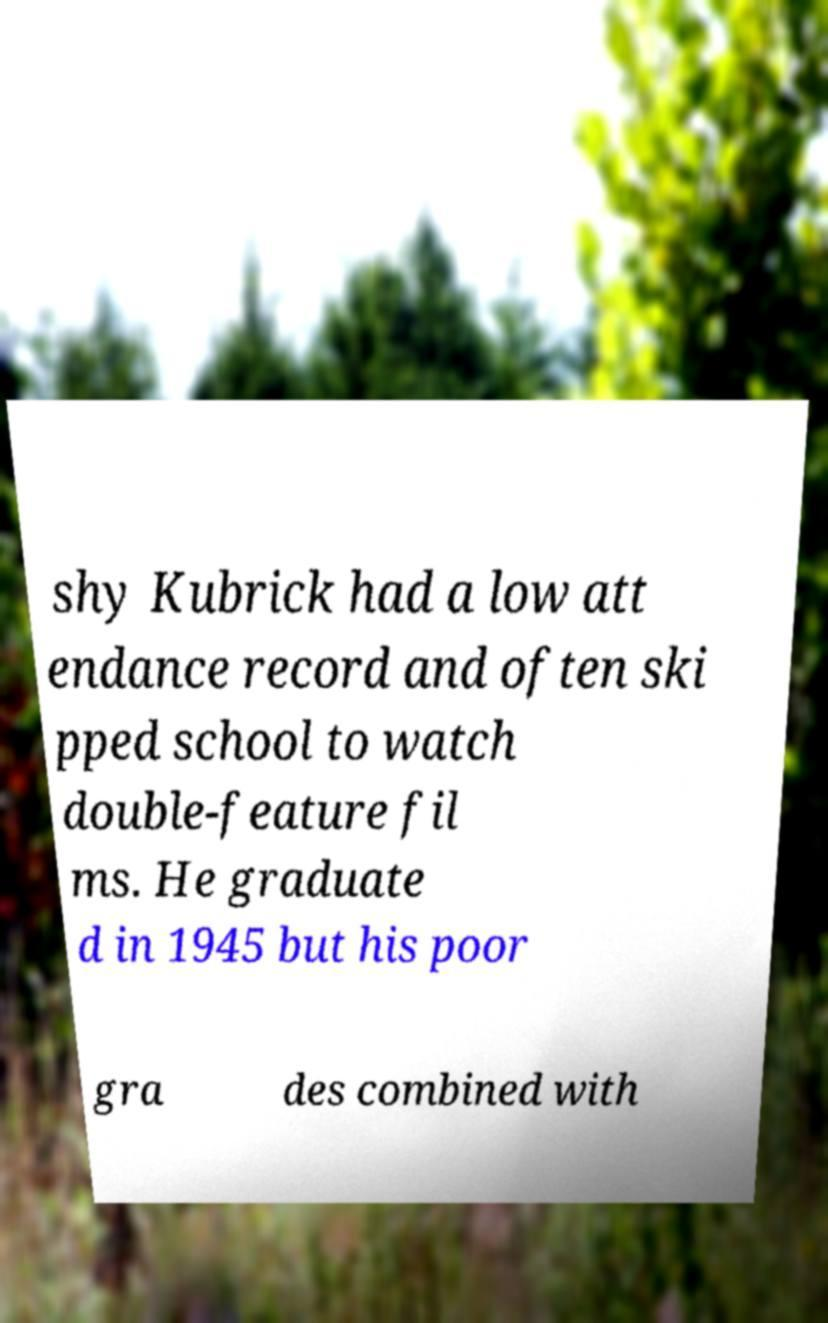Could you assist in decoding the text presented in this image and type it out clearly? shy Kubrick had a low att endance record and often ski pped school to watch double-feature fil ms. He graduate d in 1945 but his poor gra des combined with 